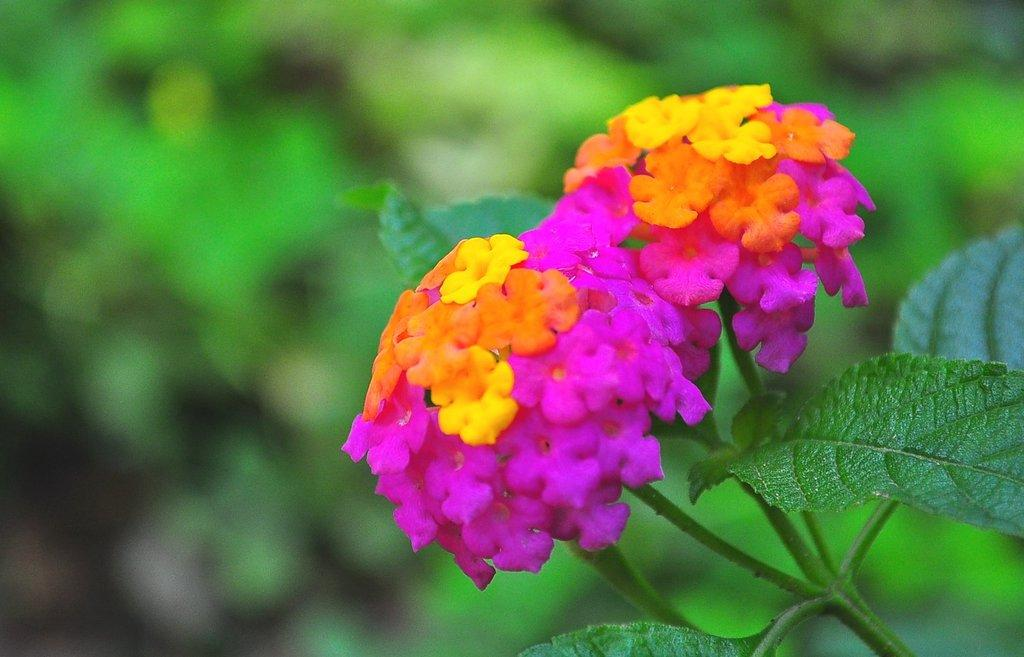What type of plants are visible in the image? There are colorful flowers in the image. Where are the flowers located? The flowers are on a plant. What can be observed about the background of the image? The background of the image is blurred. What type of ball can be seen floating in space in the image? There is no ball or space present in the image; it features colorful flowers on a plant with a blurred background. 